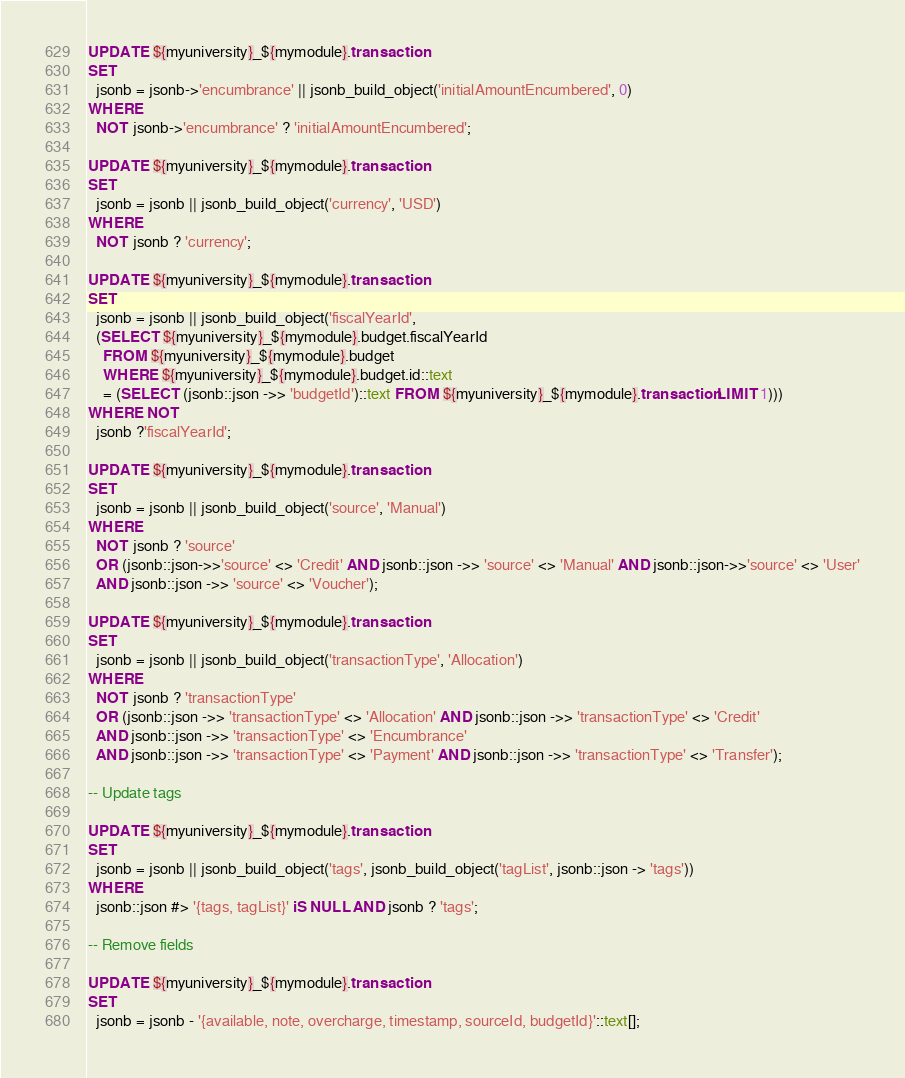Convert code to text. <code><loc_0><loc_0><loc_500><loc_500><_SQL_>
UPDATE ${myuniversity}_${mymodule}.transaction
SET
  jsonb = jsonb->'encumbrance' || jsonb_build_object('initialAmountEncumbered', 0)
WHERE
  NOT jsonb->'encumbrance' ? 'initialAmountEncumbered';

UPDATE ${myuniversity}_${mymodule}.transaction
SET
  jsonb = jsonb || jsonb_build_object('currency', 'USD')
WHERE
  NOT jsonb ? 'currency';

UPDATE ${myuniversity}_${mymodule}.transaction
SET
  jsonb = jsonb || jsonb_build_object('fiscalYearId',
  (SELECT ${myuniversity}_${mymodule}.budget.fiscalYearId
  	FROM ${myuniversity}_${mymodule}.budget
  	WHERE ${myuniversity}_${mymodule}.budget.id::text
    = (SELECT (jsonb::json ->> 'budgetId')::text FROM ${myuniversity}_${mymodule}.transaction LIMIT 1)))
WHERE NOT
  jsonb ?'fiscalYearId';

UPDATE ${myuniversity}_${mymodule}.transaction
SET
  jsonb = jsonb || jsonb_build_object('source', 'Manual')
WHERE
  NOT jsonb ? 'source'
  OR (jsonb::json->>'source' <> 'Credit' AND jsonb::json ->> 'source' <> 'Manual' AND jsonb::json->>'source' <> 'User'
  AND jsonb::json ->> 'source' <> 'Voucher');

UPDATE ${myuniversity}_${mymodule}.transaction
SET
  jsonb = jsonb || jsonb_build_object('transactionType', 'Allocation')
WHERE
  NOT jsonb ? 'transactionType'
  OR (jsonb::json ->> 'transactionType' <> 'Allocation' AND jsonb::json ->> 'transactionType' <> 'Credit'
  AND jsonb::json ->> 'transactionType' <> 'Encumbrance'
  AND jsonb::json ->> 'transactionType' <> 'Payment' AND jsonb::json ->> 'transactionType' <> 'Transfer');

-- Update tags

UPDATE ${myuniversity}_${mymodule}.transaction
SET
  jsonb = jsonb || jsonb_build_object('tags', jsonb_build_object('tagList', jsonb::json -> 'tags'))
WHERE
  jsonb::json #> '{tags, tagList}' iS NULL AND jsonb ? 'tags';

-- Remove fields

UPDATE ${myuniversity}_${mymodule}.transaction
SET
  jsonb = jsonb - '{available, note, overcharge, timestamp, sourceId, budgetId}'::text[];
</code> 